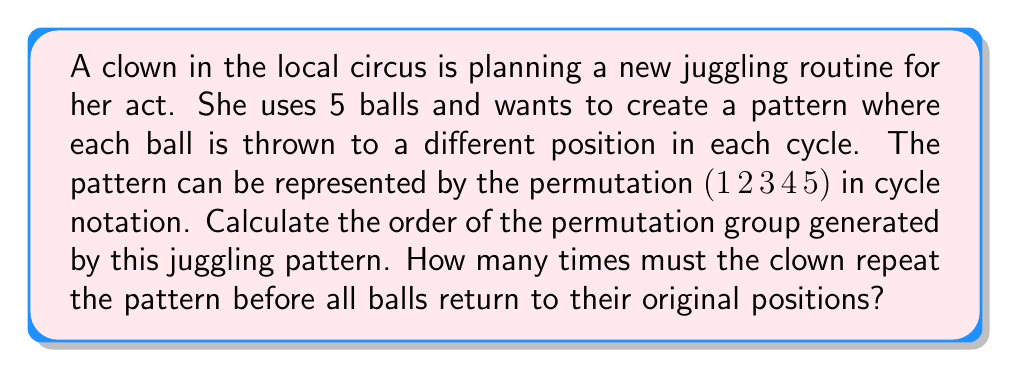Could you help me with this problem? To solve this problem, we need to understand the concept of permutation groups and their orders:

1) The given permutation $(1 \, 2 \, 3 \, 4 \, 5)$ is a cycle of length 5.

2) In group theory, the order of an element is the smallest positive integer $n$ such that $a^n = e$, where $e$ is the identity element.

3) For a cycle of length $k$, its order is always $k$.

4) In this case, the length of the cycle is 5, so the order of the permutation is 5.

5) This means that after applying the permutation 5 times, we get back to the identity permutation:

   $$(1 \, 2 \, 3 \, 4 \, 5)^5 = (1)(2)(3)(4)(5) = e$$

6) We can verify this:
   - After 1 cycle: $(1 \, 2 \, 3 \, 4 \, 5)$
   - After 2 cycles: $(1 \, 3 \, 5 \, 2 \, 4)$
   - After 3 cycles: $(1 \, 4 \, 2 \, 5 \, 3)$
   - After 4 cycles: $(1 \, 5 \, 4 \, 3 \, 2)$
   - After 5 cycles: $(1)(2)(3)(4)(5)$ (identity)

Therefore, the clown must repeat the pattern 5 times before all balls return to their original positions.
Answer: The order of the permutation group is 5. 